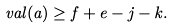<formula> <loc_0><loc_0><loc_500><loc_500>\ v a l ( a ) \geq f + e - j - k .</formula> 